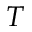<formula> <loc_0><loc_0><loc_500><loc_500>T</formula> 